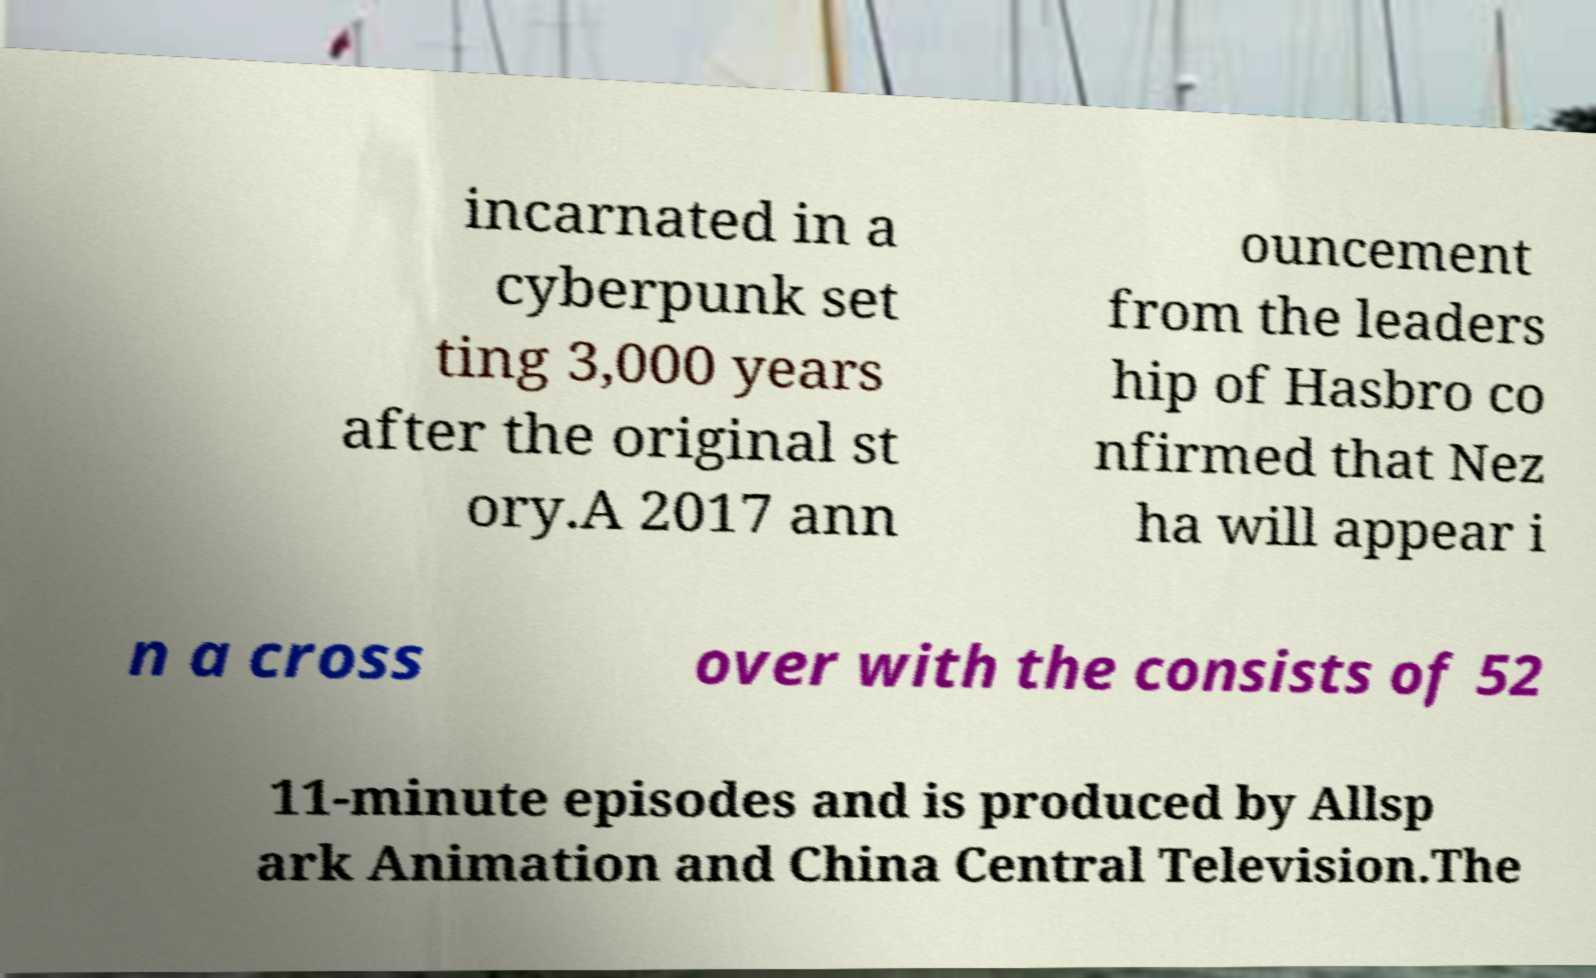Please identify and transcribe the text found in this image. incarnated in a cyberpunk set ting 3,000 years after the original st ory.A 2017 ann ouncement from the leaders hip of Hasbro co nfirmed that Nez ha will appear i n a cross over with the consists of 52 11-minute episodes and is produced by Allsp ark Animation and China Central Television.The 